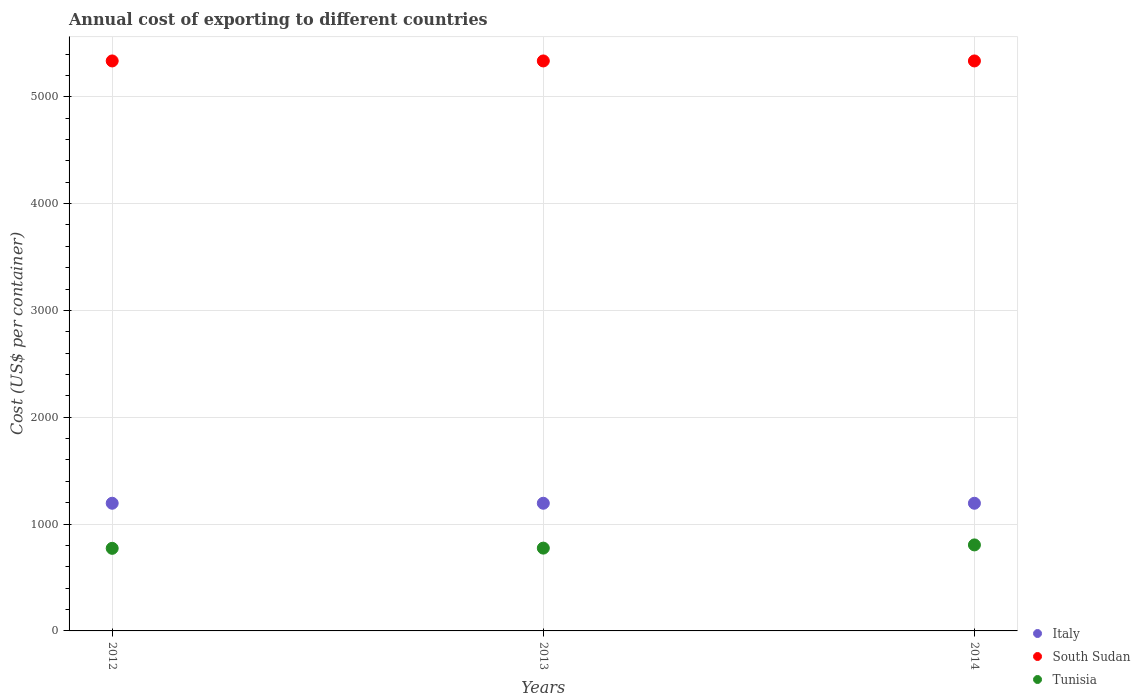Is the number of dotlines equal to the number of legend labels?
Your answer should be very brief. Yes. What is the total annual cost of exporting in Italy in 2014?
Offer a very short reply. 1195. Across all years, what is the maximum total annual cost of exporting in Italy?
Provide a succinct answer. 1195. Across all years, what is the minimum total annual cost of exporting in Tunisia?
Offer a very short reply. 773. What is the total total annual cost of exporting in Italy in the graph?
Provide a succinct answer. 3585. What is the difference between the total annual cost of exporting in South Sudan in 2012 and that in 2014?
Give a very brief answer. 0. What is the difference between the total annual cost of exporting in Italy in 2014 and the total annual cost of exporting in South Sudan in 2012?
Provide a succinct answer. -4140. What is the average total annual cost of exporting in Italy per year?
Provide a succinct answer. 1195. In the year 2012, what is the difference between the total annual cost of exporting in Tunisia and total annual cost of exporting in Italy?
Ensure brevity in your answer.  -422. In how many years, is the total annual cost of exporting in South Sudan greater than 4600 US$?
Provide a short and direct response. 3. Is the difference between the total annual cost of exporting in Tunisia in 2012 and 2013 greater than the difference between the total annual cost of exporting in Italy in 2012 and 2013?
Ensure brevity in your answer.  No. What is the difference between the highest and the lowest total annual cost of exporting in South Sudan?
Your answer should be very brief. 0. In how many years, is the total annual cost of exporting in South Sudan greater than the average total annual cost of exporting in South Sudan taken over all years?
Offer a terse response. 0. Is the sum of the total annual cost of exporting in Italy in 2012 and 2014 greater than the maximum total annual cost of exporting in South Sudan across all years?
Your answer should be very brief. No. How many dotlines are there?
Provide a succinct answer. 3. How many years are there in the graph?
Offer a very short reply. 3. Are the values on the major ticks of Y-axis written in scientific E-notation?
Offer a terse response. No. Does the graph contain any zero values?
Your response must be concise. No. How many legend labels are there?
Provide a short and direct response. 3. How are the legend labels stacked?
Your answer should be compact. Vertical. What is the title of the graph?
Offer a very short reply. Annual cost of exporting to different countries. Does "South Africa" appear as one of the legend labels in the graph?
Your response must be concise. No. What is the label or title of the Y-axis?
Offer a terse response. Cost (US$ per container). What is the Cost (US$ per container) in Italy in 2012?
Your response must be concise. 1195. What is the Cost (US$ per container) in South Sudan in 2012?
Your answer should be very brief. 5335. What is the Cost (US$ per container) of Tunisia in 2012?
Offer a terse response. 773. What is the Cost (US$ per container) of Italy in 2013?
Your response must be concise. 1195. What is the Cost (US$ per container) of South Sudan in 2013?
Offer a very short reply. 5335. What is the Cost (US$ per container) in Tunisia in 2013?
Your answer should be very brief. 775. What is the Cost (US$ per container) in Italy in 2014?
Give a very brief answer. 1195. What is the Cost (US$ per container) in South Sudan in 2014?
Give a very brief answer. 5335. What is the Cost (US$ per container) of Tunisia in 2014?
Offer a very short reply. 805. Across all years, what is the maximum Cost (US$ per container) of Italy?
Provide a short and direct response. 1195. Across all years, what is the maximum Cost (US$ per container) of South Sudan?
Offer a very short reply. 5335. Across all years, what is the maximum Cost (US$ per container) of Tunisia?
Provide a succinct answer. 805. Across all years, what is the minimum Cost (US$ per container) in Italy?
Your answer should be very brief. 1195. Across all years, what is the minimum Cost (US$ per container) in South Sudan?
Offer a terse response. 5335. Across all years, what is the minimum Cost (US$ per container) in Tunisia?
Your answer should be compact. 773. What is the total Cost (US$ per container) in Italy in the graph?
Provide a short and direct response. 3585. What is the total Cost (US$ per container) in South Sudan in the graph?
Offer a terse response. 1.60e+04. What is the total Cost (US$ per container) of Tunisia in the graph?
Give a very brief answer. 2353. What is the difference between the Cost (US$ per container) in Italy in 2012 and that in 2013?
Ensure brevity in your answer.  0. What is the difference between the Cost (US$ per container) in South Sudan in 2012 and that in 2013?
Your answer should be compact. 0. What is the difference between the Cost (US$ per container) of Tunisia in 2012 and that in 2014?
Your answer should be very brief. -32. What is the difference between the Cost (US$ per container) in Italy in 2013 and that in 2014?
Provide a succinct answer. 0. What is the difference between the Cost (US$ per container) in South Sudan in 2013 and that in 2014?
Provide a short and direct response. 0. What is the difference between the Cost (US$ per container) in Italy in 2012 and the Cost (US$ per container) in South Sudan in 2013?
Offer a very short reply. -4140. What is the difference between the Cost (US$ per container) in Italy in 2012 and the Cost (US$ per container) in Tunisia in 2013?
Your answer should be very brief. 420. What is the difference between the Cost (US$ per container) of South Sudan in 2012 and the Cost (US$ per container) of Tunisia in 2013?
Ensure brevity in your answer.  4560. What is the difference between the Cost (US$ per container) in Italy in 2012 and the Cost (US$ per container) in South Sudan in 2014?
Your answer should be very brief. -4140. What is the difference between the Cost (US$ per container) in Italy in 2012 and the Cost (US$ per container) in Tunisia in 2014?
Provide a short and direct response. 390. What is the difference between the Cost (US$ per container) in South Sudan in 2012 and the Cost (US$ per container) in Tunisia in 2014?
Offer a very short reply. 4530. What is the difference between the Cost (US$ per container) in Italy in 2013 and the Cost (US$ per container) in South Sudan in 2014?
Your response must be concise. -4140. What is the difference between the Cost (US$ per container) in Italy in 2013 and the Cost (US$ per container) in Tunisia in 2014?
Provide a succinct answer. 390. What is the difference between the Cost (US$ per container) of South Sudan in 2013 and the Cost (US$ per container) of Tunisia in 2014?
Keep it short and to the point. 4530. What is the average Cost (US$ per container) of Italy per year?
Provide a succinct answer. 1195. What is the average Cost (US$ per container) in South Sudan per year?
Make the answer very short. 5335. What is the average Cost (US$ per container) in Tunisia per year?
Ensure brevity in your answer.  784.33. In the year 2012, what is the difference between the Cost (US$ per container) of Italy and Cost (US$ per container) of South Sudan?
Offer a very short reply. -4140. In the year 2012, what is the difference between the Cost (US$ per container) in Italy and Cost (US$ per container) in Tunisia?
Your response must be concise. 422. In the year 2012, what is the difference between the Cost (US$ per container) of South Sudan and Cost (US$ per container) of Tunisia?
Provide a short and direct response. 4562. In the year 2013, what is the difference between the Cost (US$ per container) of Italy and Cost (US$ per container) of South Sudan?
Make the answer very short. -4140. In the year 2013, what is the difference between the Cost (US$ per container) of Italy and Cost (US$ per container) of Tunisia?
Your answer should be very brief. 420. In the year 2013, what is the difference between the Cost (US$ per container) of South Sudan and Cost (US$ per container) of Tunisia?
Ensure brevity in your answer.  4560. In the year 2014, what is the difference between the Cost (US$ per container) in Italy and Cost (US$ per container) in South Sudan?
Your answer should be compact. -4140. In the year 2014, what is the difference between the Cost (US$ per container) in Italy and Cost (US$ per container) in Tunisia?
Your answer should be very brief. 390. In the year 2014, what is the difference between the Cost (US$ per container) of South Sudan and Cost (US$ per container) of Tunisia?
Your response must be concise. 4530. What is the ratio of the Cost (US$ per container) of South Sudan in 2012 to that in 2013?
Your response must be concise. 1. What is the ratio of the Cost (US$ per container) of Italy in 2012 to that in 2014?
Give a very brief answer. 1. What is the ratio of the Cost (US$ per container) of Tunisia in 2012 to that in 2014?
Make the answer very short. 0.96. What is the ratio of the Cost (US$ per container) of Italy in 2013 to that in 2014?
Your answer should be very brief. 1. What is the ratio of the Cost (US$ per container) of Tunisia in 2013 to that in 2014?
Your answer should be compact. 0.96. What is the difference between the highest and the second highest Cost (US$ per container) of Italy?
Your response must be concise. 0. What is the difference between the highest and the second highest Cost (US$ per container) in South Sudan?
Your answer should be compact. 0. What is the difference between the highest and the second highest Cost (US$ per container) in Tunisia?
Provide a short and direct response. 30. 